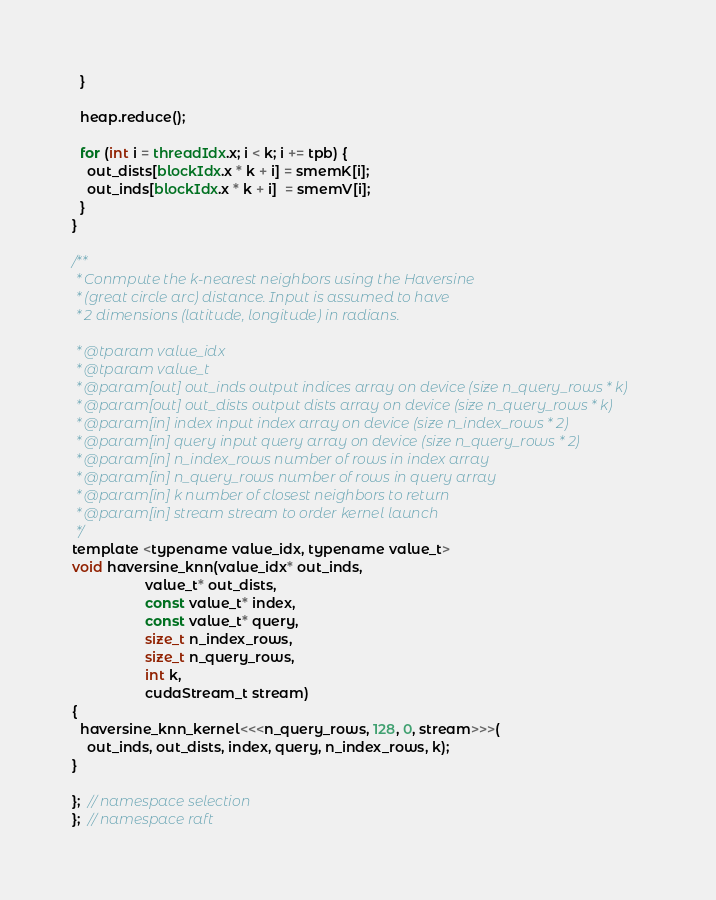Convert code to text. <code><loc_0><loc_0><loc_500><loc_500><_Cuda_>  }

  heap.reduce();

  for (int i = threadIdx.x; i < k; i += tpb) {
    out_dists[blockIdx.x * k + i] = smemK[i];
    out_inds[blockIdx.x * k + i]  = smemV[i];
  }
}

/**
 * Conmpute the k-nearest neighbors using the Haversine
 * (great circle arc) distance. Input is assumed to have
 * 2 dimensions (latitude, longitude) in radians.

 * @tparam value_idx
 * @tparam value_t
 * @param[out] out_inds output indices array on device (size n_query_rows * k)
 * @param[out] out_dists output dists array on device (size n_query_rows * k)
 * @param[in] index input index array on device (size n_index_rows * 2)
 * @param[in] query input query array on device (size n_query_rows * 2)
 * @param[in] n_index_rows number of rows in index array
 * @param[in] n_query_rows number of rows in query array
 * @param[in] k number of closest neighbors to return
 * @param[in] stream stream to order kernel launch
 */
template <typename value_idx, typename value_t>
void haversine_knn(value_idx* out_inds,
                   value_t* out_dists,
                   const value_t* index,
                   const value_t* query,
                   size_t n_index_rows,
                   size_t n_query_rows,
                   int k,
                   cudaStream_t stream)
{
  haversine_knn_kernel<<<n_query_rows, 128, 0, stream>>>(
    out_inds, out_dists, index, query, n_index_rows, k);
}

};  // namespace selection
};  // namespace raft
</code> 